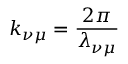Convert formula to latex. <formula><loc_0><loc_0><loc_500><loc_500>k _ { \nu \mu } = \frac { 2 \pi } { \lambda _ { \nu \mu } }</formula> 